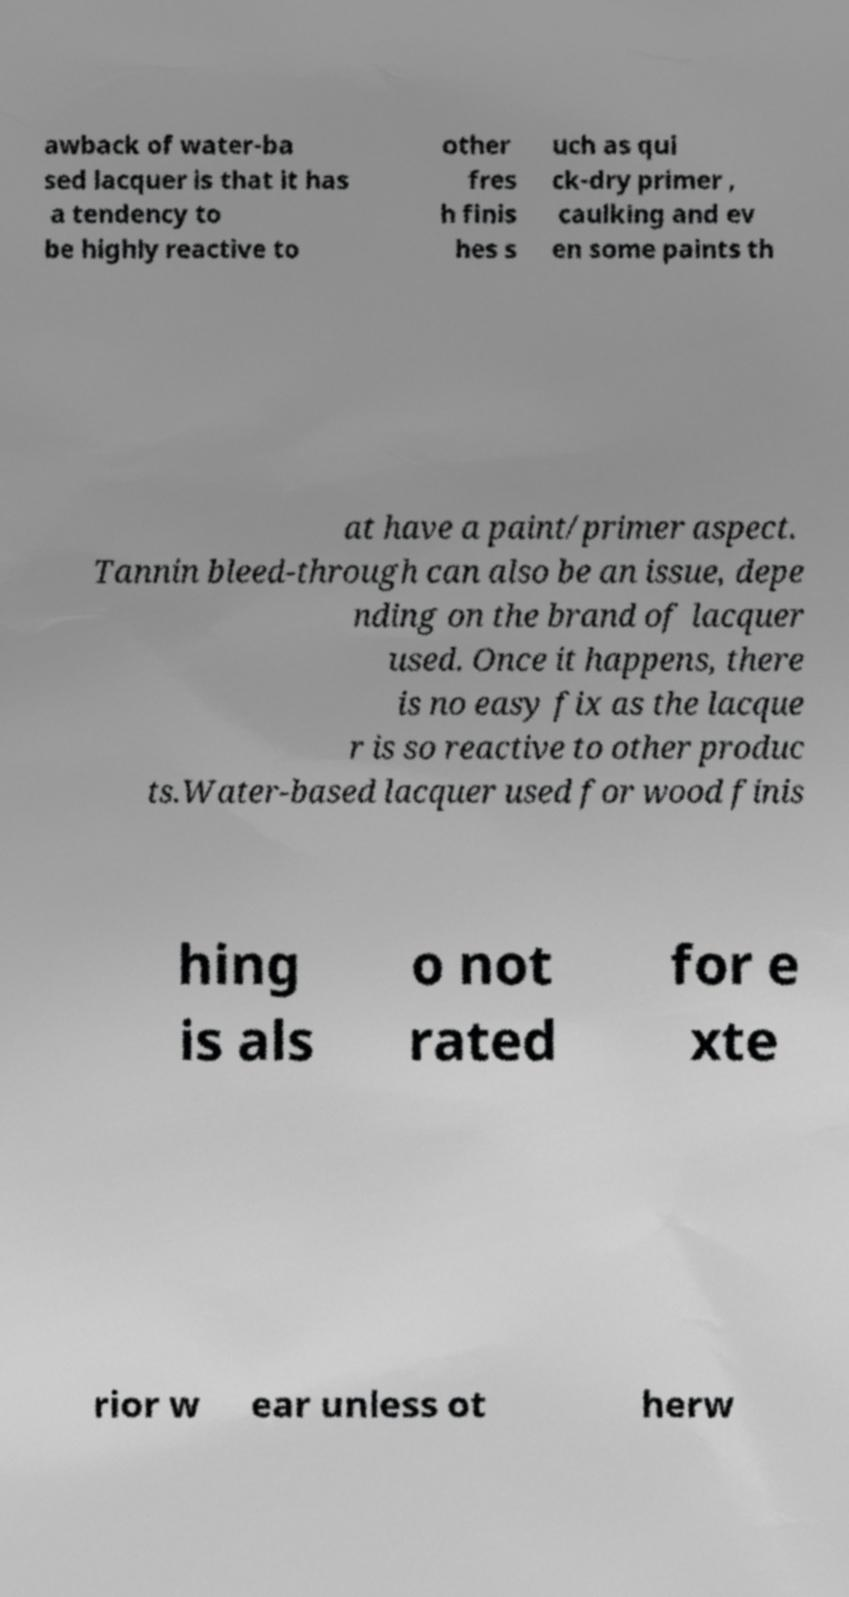Could you assist in decoding the text presented in this image and type it out clearly? awback of water-ba sed lacquer is that it has a tendency to be highly reactive to other fres h finis hes s uch as qui ck-dry primer , caulking and ev en some paints th at have a paint/primer aspect. Tannin bleed-through can also be an issue, depe nding on the brand of lacquer used. Once it happens, there is no easy fix as the lacque r is so reactive to other produc ts.Water-based lacquer used for wood finis hing is als o not rated for e xte rior w ear unless ot herw 